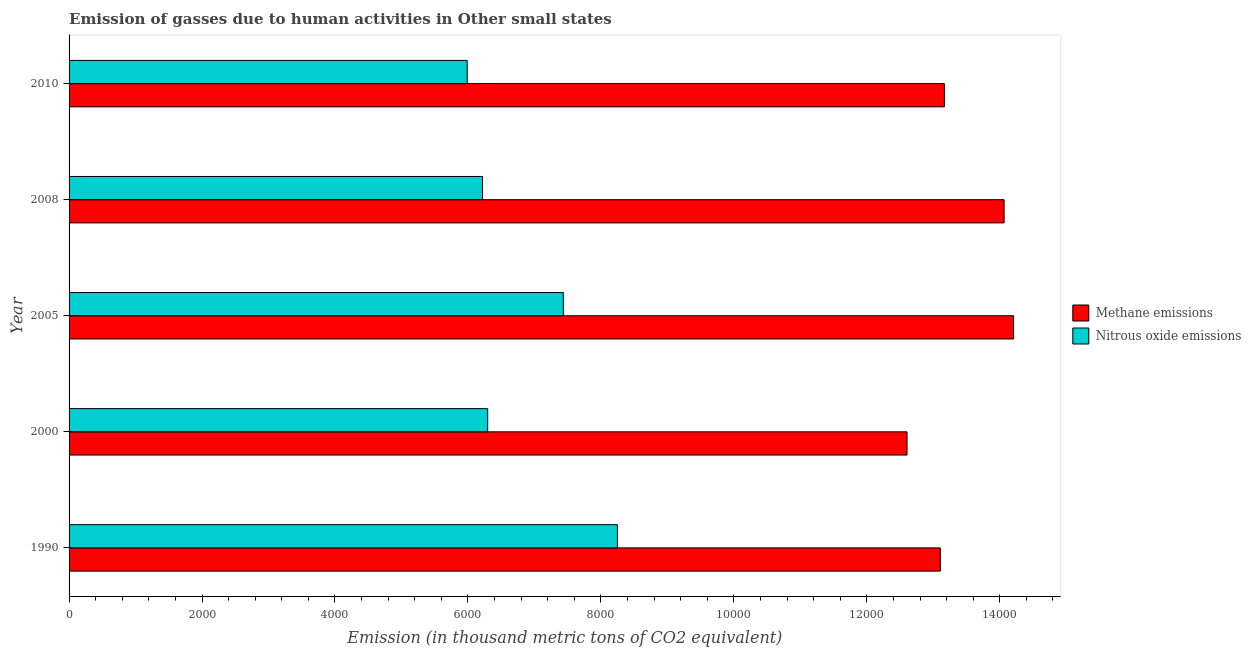How many different coloured bars are there?
Provide a short and direct response. 2. Are the number of bars per tick equal to the number of legend labels?
Give a very brief answer. Yes. Are the number of bars on each tick of the Y-axis equal?
Offer a very short reply. Yes. What is the label of the 3rd group of bars from the top?
Your response must be concise. 2005. What is the amount of nitrous oxide emissions in 2005?
Provide a short and direct response. 7434.8. Across all years, what is the maximum amount of methane emissions?
Make the answer very short. 1.42e+04. Across all years, what is the minimum amount of nitrous oxide emissions?
Your response must be concise. 5988.7. What is the total amount of nitrous oxide emissions in the graph?
Provide a succinct answer. 3.42e+04. What is the difference between the amount of methane emissions in 1990 and that in 2000?
Give a very brief answer. 501.1. What is the difference between the amount of nitrous oxide emissions in 2000 and the amount of methane emissions in 2005?
Offer a terse response. -7910.3. What is the average amount of nitrous oxide emissions per year?
Your answer should be very brief. 6837.7. In the year 2005, what is the difference between the amount of methane emissions and amount of nitrous oxide emissions?
Your answer should be compact. 6772.5. In how many years, is the amount of methane emissions greater than 14400 thousand metric tons?
Offer a very short reply. 0. What is the ratio of the amount of methane emissions in 1990 to that in 2000?
Ensure brevity in your answer.  1.04. What is the difference between the highest and the second highest amount of methane emissions?
Make the answer very short. 142.1. What is the difference between the highest and the lowest amount of methane emissions?
Your answer should be very brief. 1602.4. In how many years, is the amount of nitrous oxide emissions greater than the average amount of nitrous oxide emissions taken over all years?
Offer a very short reply. 2. What does the 2nd bar from the top in 2005 represents?
Your response must be concise. Methane emissions. What does the 1st bar from the bottom in 2005 represents?
Offer a very short reply. Methane emissions. How many years are there in the graph?
Give a very brief answer. 5. What is the difference between two consecutive major ticks on the X-axis?
Offer a very short reply. 2000. Does the graph contain grids?
Your response must be concise. No. Where does the legend appear in the graph?
Provide a short and direct response. Center right. How many legend labels are there?
Offer a terse response. 2. What is the title of the graph?
Ensure brevity in your answer.  Emission of gasses due to human activities in Other small states. Does "From Government" appear as one of the legend labels in the graph?
Provide a short and direct response. No. What is the label or title of the X-axis?
Ensure brevity in your answer.  Emission (in thousand metric tons of CO2 equivalent). What is the Emission (in thousand metric tons of CO2 equivalent) in Methane emissions in 1990?
Offer a terse response. 1.31e+04. What is the Emission (in thousand metric tons of CO2 equivalent) of Nitrous oxide emissions in 1990?
Keep it short and to the point. 8248.7. What is the Emission (in thousand metric tons of CO2 equivalent) of Methane emissions in 2000?
Offer a very short reply. 1.26e+04. What is the Emission (in thousand metric tons of CO2 equivalent) in Nitrous oxide emissions in 2000?
Provide a short and direct response. 6297. What is the Emission (in thousand metric tons of CO2 equivalent) of Methane emissions in 2005?
Keep it short and to the point. 1.42e+04. What is the Emission (in thousand metric tons of CO2 equivalent) of Nitrous oxide emissions in 2005?
Your answer should be very brief. 7434.8. What is the Emission (in thousand metric tons of CO2 equivalent) of Methane emissions in 2008?
Ensure brevity in your answer.  1.41e+04. What is the Emission (in thousand metric tons of CO2 equivalent) of Nitrous oxide emissions in 2008?
Your answer should be compact. 6219.3. What is the Emission (in thousand metric tons of CO2 equivalent) in Methane emissions in 2010?
Your response must be concise. 1.32e+04. What is the Emission (in thousand metric tons of CO2 equivalent) of Nitrous oxide emissions in 2010?
Give a very brief answer. 5988.7. Across all years, what is the maximum Emission (in thousand metric tons of CO2 equivalent) in Methane emissions?
Give a very brief answer. 1.42e+04. Across all years, what is the maximum Emission (in thousand metric tons of CO2 equivalent) of Nitrous oxide emissions?
Your response must be concise. 8248.7. Across all years, what is the minimum Emission (in thousand metric tons of CO2 equivalent) in Methane emissions?
Provide a short and direct response. 1.26e+04. Across all years, what is the minimum Emission (in thousand metric tons of CO2 equivalent) of Nitrous oxide emissions?
Your answer should be compact. 5988.7. What is the total Emission (in thousand metric tons of CO2 equivalent) in Methane emissions in the graph?
Your response must be concise. 6.72e+04. What is the total Emission (in thousand metric tons of CO2 equivalent) in Nitrous oxide emissions in the graph?
Make the answer very short. 3.42e+04. What is the difference between the Emission (in thousand metric tons of CO2 equivalent) in Methane emissions in 1990 and that in 2000?
Ensure brevity in your answer.  501.1. What is the difference between the Emission (in thousand metric tons of CO2 equivalent) of Nitrous oxide emissions in 1990 and that in 2000?
Provide a short and direct response. 1951.7. What is the difference between the Emission (in thousand metric tons of CO2 equivalent) in Methane emissions in 1990 and that in 2005?
Ensure brevity in your answer.  -1101.3. What is the difference between the Emission (in thousand metric tons of CO2 equivalent) in Nitrous oxide emissions in 1990 and that in 2005?
Offer a very short reply. 813.9. What is the difference between the Emission (in thousand metric tons of CO2 equivalent) in Methane emissions in 1990 and that in 2008?
Offer a very short reply. -959.2. What is the difference between the Emission (in thousand metric tons of CO2 equivalent) of Nitrous oxide emissions in 1990 and that in 2008?
Offer a very short reply. 2029.4. What is the difference between the Emission (in thousand metric tons of CO2 equivalent) in Methane emissions in 1990 and that in 2010?
Offer a very short reply. -60.7. What is the difference between the Emission (in thousand metric tons of CO2 equivalent) in Nitrous oxide emissions in 1990 and that in 2010?
Make the answer very short. 2260. What is the difference between the Emission (in thousand metric tons of CO2 equivalent) of Methane emissions in 2000 and that in 2005?
Give a very brief answer. -1602.4. What is the difference between the Emission (in thousand metric tons of CO2 equivalent) of Nitrous oxide emissions in 2000 and that in 2005?
Offer a terse response. -1137.8. What is the difference between the Emission (in thousand metric tons of CO2 equivalent) in Methane emissions in 2000 and that in 2008?
Make the answer very short. -1460.3. What is the difference between the Emission (in thousand metric tons of CO2 equivalent) in Nitrous oxide emissions in 2000 and that in 2008?
Keep it short and to the point. 77.7. What is the difference between the Emission (in thousand metric tons of CO2 equivalent) of Methane emissions in 2000 and that in 2010?
Give a very brief answer. -561.8. What is the difference between the Emission (in thousand metric tons of CO2 equivalent) of Nitrous oxide emissions in 2000 and that in 2010?
Your response must be concise. 308.3. What is the difference between the Emission (in thousand metric tons of CO2 equivalent) of Methane emissions in 2005 and that in 2008?
Your answer should be very brief. 142.1. What is the difference between the Emission (in thousand metric tons of CO2 equivalent) of Nitrous oxide emissions in 2005 and that in 2008?
Give a very brief answer. 1215.5. What is the difference between the Emission (in thousand metric tons of CO2 equivalent) of Methane emissions in 2005 and that in 2010?
Your answer should be compact. 1040.6. What is the difference between the Emission (in thousand metric tons of CO2 equivalent) of Nitrous oxide emissions in 2005 and that in 2010?
Offer a terse response. 1446.1. What is the difference between the Emission (in thousand metric tons of CO2 equivalent) in Methane emissions in 2008 and that in 2010?
Provide a succinct answer. 898.5. What is the difference between the Emission (in thousand metric tons of CO2 equivalent) of Nitrous oxide emissions in 2008 and that in 2010?
Offer a terse response. 230.6. What is the difference between the Emission (in thousand metric tons of CO2 equivalent) of Methane emissions in 1990 and the Emission (in thousand metric tons of CO2 equivalent) of Nitrous oxide emissions in 2000?
Offer a very short reply. 6809. What is the difference between the Emission (in thousand metric tons of CO2 equivalent) in Methane emissions in 1990 and the Emission (in thousand metric tons of CO2 equivalent) in Nitrous oxide emissions in 2005?
Keep it short and to the point. 5671.2. What is the difference between the Emission (in thousand metric tons of CO2 equivalent) in Methane emissions in 1990 and the Emission (in thousand metric tons of CO2 equivalent) in Nitrous oxide emissions in 2008?
Make the answer very short. 6886.7. What is the difference between the Emission (in thousand metric tons of CO2 equivalent) in Methane emissions in 1990 and the Emission (in thousand metric tons of CO2 equivalent) in Nitrous oxide emissions in 2010?
Your response must be concise. 7117.3. What is the difference between the Emission (in thousand metric tons of CO2 equivalent) of Methane emissions in 2000 and the Emission (in thousand metric tons of CO2 equivalent) of Nitrous oxide emissions in 2005?
Give a very brief answer. 5170.1. What is the difference between the Emission (in thousand metric tons of CO2 equivalent) of Methane emissions in 2000 and the Emission (in thousand metric tons of CO2 equivalent) of Nitrous oxide emissions in 2008?
Provide a succinct answer. 6385.6. What is the difference between the Emission (in thousand metric tons of CO2 equivalent) in Methane emissions in 2000 and the Emission (in thousand metric tons of CO2 equivalent) in Nitrous oxide emissions in 2010?
Your answer should be compact. 6616.2. What is the difference between the Emission (in thousand metric tons of CO2 equivalent) of Methane emissions in 2005 and the Emission (in thousand metric tons of CO2 equivalent) of Nitrous oxide emissions in 2008?
Your answer should be compact. 7988. What is the difference between the Emission (in thousand metric tons of CO2 equivalent) of Methane emissions in 2005 and the Emission (in thousand metric tons of CO2 equivalent) of Nitrous oxide emissions in 2010?
Offer a terse response. 8218.6. What is the difference between the Emission (in thousand metric tons of CO2 equivalent) in Methane emissions in 2008 and the Emission (in thousand metric tons of CO2 equivalent) in Nitrous oxide emissions in 2010?
Provide a short and direct response. 8076.5. What is the average Emission (in thousand metric tons of CO2 equivalent) in Methane emissions per year?
Ensure brevity in your answer.  1.34e+04. What is the average Emission (in thousand metric tons of CO2 equivalent) of Nitrous oxide emissions per year?
Ensure brevity in your answer.  6837.7. In the year 1990, what is the difference between the Emission (in thousand metric tons of CO2 equivalent) in Methane emissions and Emission (in thousand metric tons of CO2 equivalent) in Nitrous oxide emissions?
Offer a terse response. 4857.3. In the year 2000, what is the difference between the Emission (in thousand metric tons of CO2 equivalent) in Methane emissions and Emission (in thousand metric tons of CO2 equivalent) in Nitrous oxide emissions?
Give a very brief answer. 6307.9. In the year 2005, what is the difference between the Emission (in thousand metric tons of CO2 equivalent) of Methane emissions and Emission (in thousand metric tons of CO2 equivalent) of Nitrous oxide emissions?
Offer a very short reply. 6772.5. In the year 2008, what is the difference between the Emission (in thousand metric tons of CO2 equivalent) of Methane emissions and Emission (in thousand metric tons of CO2 equivalent) of Nitrous oxide emissions?
Provide a short and direct response. 7845.9. In the year 2010, what is the difference between the Emission (in thousand metric tons of CO2 equivalent) in Methane emissions and Emission (in thousand metric tons of CO2 equivalent) in Nitrous oxide emissions?
Keep it short and to the point. 7178. What is the ratio of the Emission (in thousand metric tons of CO2 equivalent) in Methane emissions in 1990 to that in 2000?
Give a very brief answer. 1.04. What is the ratio of the Emission (in thousand metric tons of CO2 equivalent) of Nitrous oxide emissions in 1990 to that in 2000?
Provide a succinct answer. 1.31. What is the ratio of the Emission (in thousand metric tons of CO2 equivalent) of Methane emissions in 1990 to that in 2005?
Give a very brief answer. 0.92. What is the ratio of the Emission (in thousand metric tons of CO2 equivalent) in Nitrous oxide emissions in 1990 to that in 2005?
Your answer should be very brief. 1.11. What is the ratio of the Emission (in thousand metric tons of CO2 equivalent) of Methane emissions in 1990 to that in 2008?
Your answer should be very brief. 0.93. What is the ratio of the Emission (in thousand metric tons of CO2 equivalent) in Nitrous oxide emissions in 1990 to that in 2008?
Ensure brevity in your answer.  1.33. What is the ratio of the Emission (in thousand metric tons of CO2 equivalent) of Nitrous oxide emissions in 1990 to that in 2010?
Give a very brief answer. 1.38. What is the ratio of the Emission (in thousand metric tons of CO2 equivalent) of Methane emissions in 2000 to that in 2005?
Your response must be concise. 0.89. What is the ratio of the Emission (in thousand metric tons of CO2 equivalent) of Nitrous oxide emissions in 2000 to that in 2005?
Ensure brevity in your answer.  0.85. What is the ratio of the Emission (in thousand metric tons of CO2 equivalent) in Methane emissions in 2000 to that in 2008?
Offer a very short reply. 0.9. What is the ratio of the Emission (in thousand metric tons of CO2 equivalent) of Nitrous oxide emissions in 2000 to that in 2008?
Offer a terse response. 1.01. What is the ratio of the Emission (in thousand metric tons of CO2 equivalent) of Methane emissions in 2000 to that in 2010?
Offer a very short reply. 0.96. What is the ratio of the Emission (in thousand metric tons of CO2 equivalent) of Nitrous oxide emissions in 2000 to that in 2010?
Make the answer very short. 1.05. What is the ratio of the Emission (in thousand metric tons of CO2 equivalent) in Methane emissions in 2005 to that in 2008?
Your answer should be very brief. 1.01. What is the ratio of the Emission (in thousand metric tons of CO2 equivalent) in Nitrous oxide emissions in 2005 to that in 2008?
Your answer should be very brief. 1.2. What is the ratio of the Emission (in thousand metric tons of CO2 equivalent) in Methane emissions in 2005 to that in 2010?
Offer a terse response. 1.08. What is the ratio of the Emission (in thousand metric tons of CO2 equivalent) in Nitrous oxide emissions in 2005 to that in 2010?
Your answer should be compact. 1.24. What is the ratio of the Emission (in thousand metric tons of CO2 equivalent) of Methane emissions in 2008 to that in 2010?
Offer a very short reply. 1.07. What is the difference between the highest and the second highest Emission (in thousand metric tons of CO2 equivalent) of Methane emissions?
Offer a very short reply. 142.1. What is the difference between the highest and the second highest Emission (in thousand metric tons of CO2 equivalent) in Nitrous oxide emissions?
Your response must be concise. 813.9. What is the difference between the highest and the lowest Emission (in thousand metric tons of CO2 equivalent) of Methane emissions?
Give a very brief answer. 1602.4. What is the difference between the highest and the lowest Emission (in thousand metric tons of CO2 equivalent) of Nitrous oxide emissions?
Ensure brevity in your answer.  2260. 